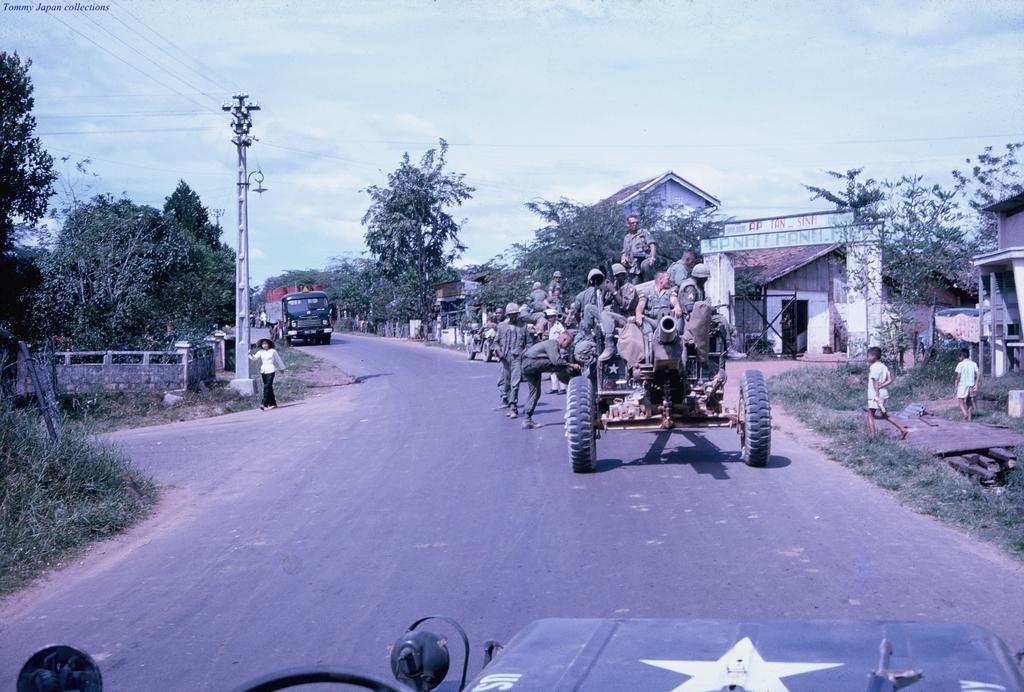In one or two sentences, can you explain what this image depicts? In this image there are some persons sitting on the vehicle as we can see in middle of this image, and there is a road at left side to this image. There is one vehicle at bottom of this image and there is one another vehicle at top of this image. There are some trees in the background. there are some buildings at right side of this image. There is a current pole at left side of this image 